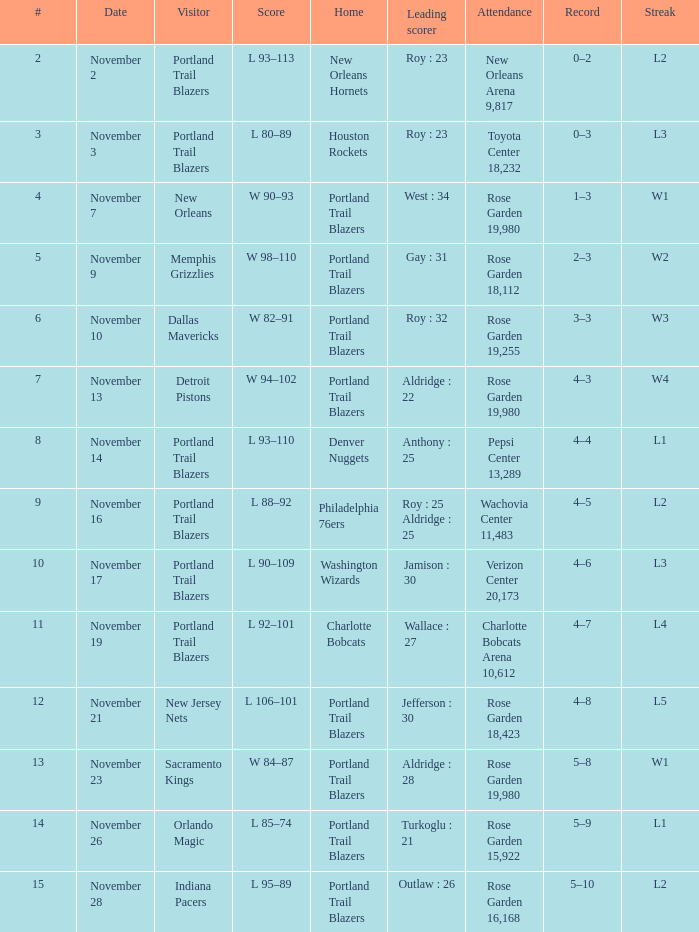How many records are there where the streak equals l2 and roy is the leading scorer with 23 points? 1.0. 